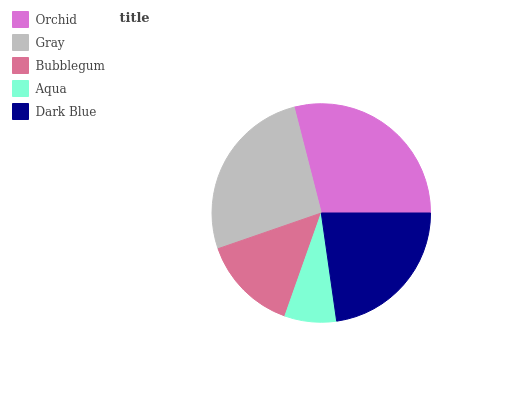Is Aqua the minimum?
Answer yes or no. Yes. Is Orchid the maximum?
Answer yes or no. Yes. Is Gray the minimum?
Answer yes or no. No. Is Gray the maximum?
Answer yes or no. No. Is Orchid greater than Gray?
Answer yes or no. Yes. Is Gray less than Orchid?
Answer yes or no. Yes. Is Gray greater than Orchid?
Answer yes or no. No. Is Orchid less than Gray?
Answer yes or no. No. Is Dark Blue the high median?
Answer yes or no. Yes. Is Dark Blue the low median?
Answer yes or no. Yes. Is Aqua the high median?
Answer yes or no. No. Is Aqua the low median?
Answer yes or no. No. 